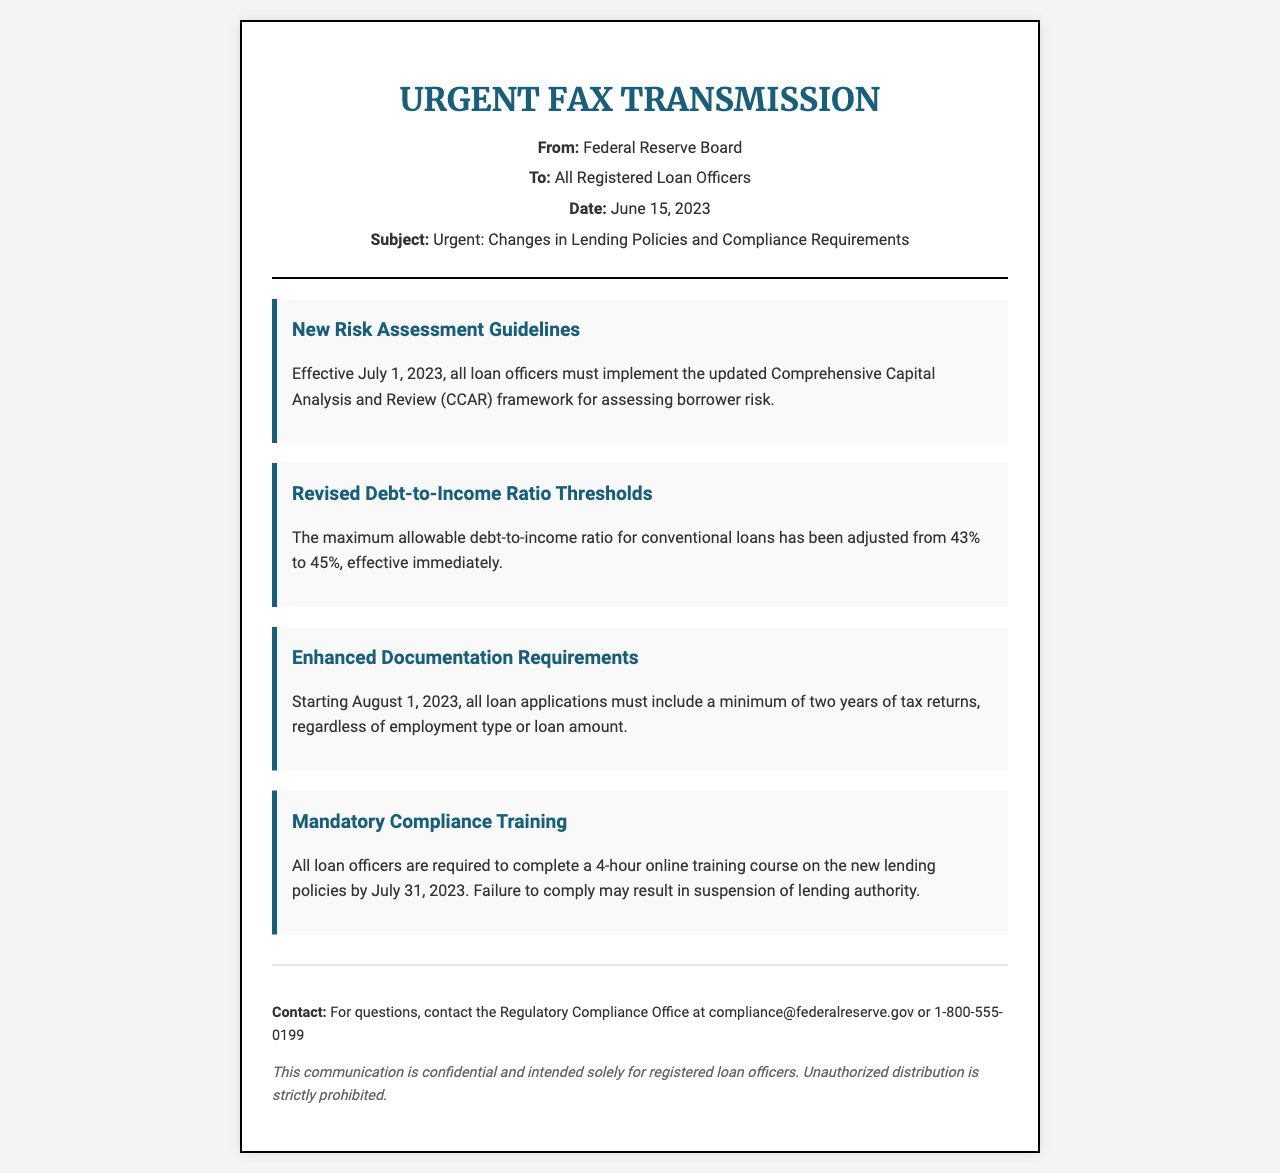What is the date of the fax? The date of the fax is mentioned in the header section of the document, indicating when it was sent.
Answer: June 15, 2023 What is the maximum allowable debt-to-income ratio for conventional loans? The revised thresholds for the debt-to-income ratio are stated explicitly in the document.
Answer: 45% When do the new risk assessment guidelines take effect? The effective date for the updated guidelines is provided in the document.
Answer: July 1, 2023 How long is the mandatory compliance training course? The duration of the training course is explicitly stated in the document.
Answer: 4-hour What is required for all loan applications starting August 1, 2023? The document specifies new documentation requirements for loan applications.
Answer: Two years of tax returns Who should be contacted for questions regarding compliance? Contact information for queries is provided in the footer of the document.
Answer: compliance@federalreserve.gov What could happen if a loan officer fails to complete the compliance training? The consequences of failing to comply with the training requirement are outlined in the document.
Answer: Suspension of lending authority What is the title of the fax? The title of the fax is highlighted in the header section.
Answer: URGENT FAX TRANSMISSION 